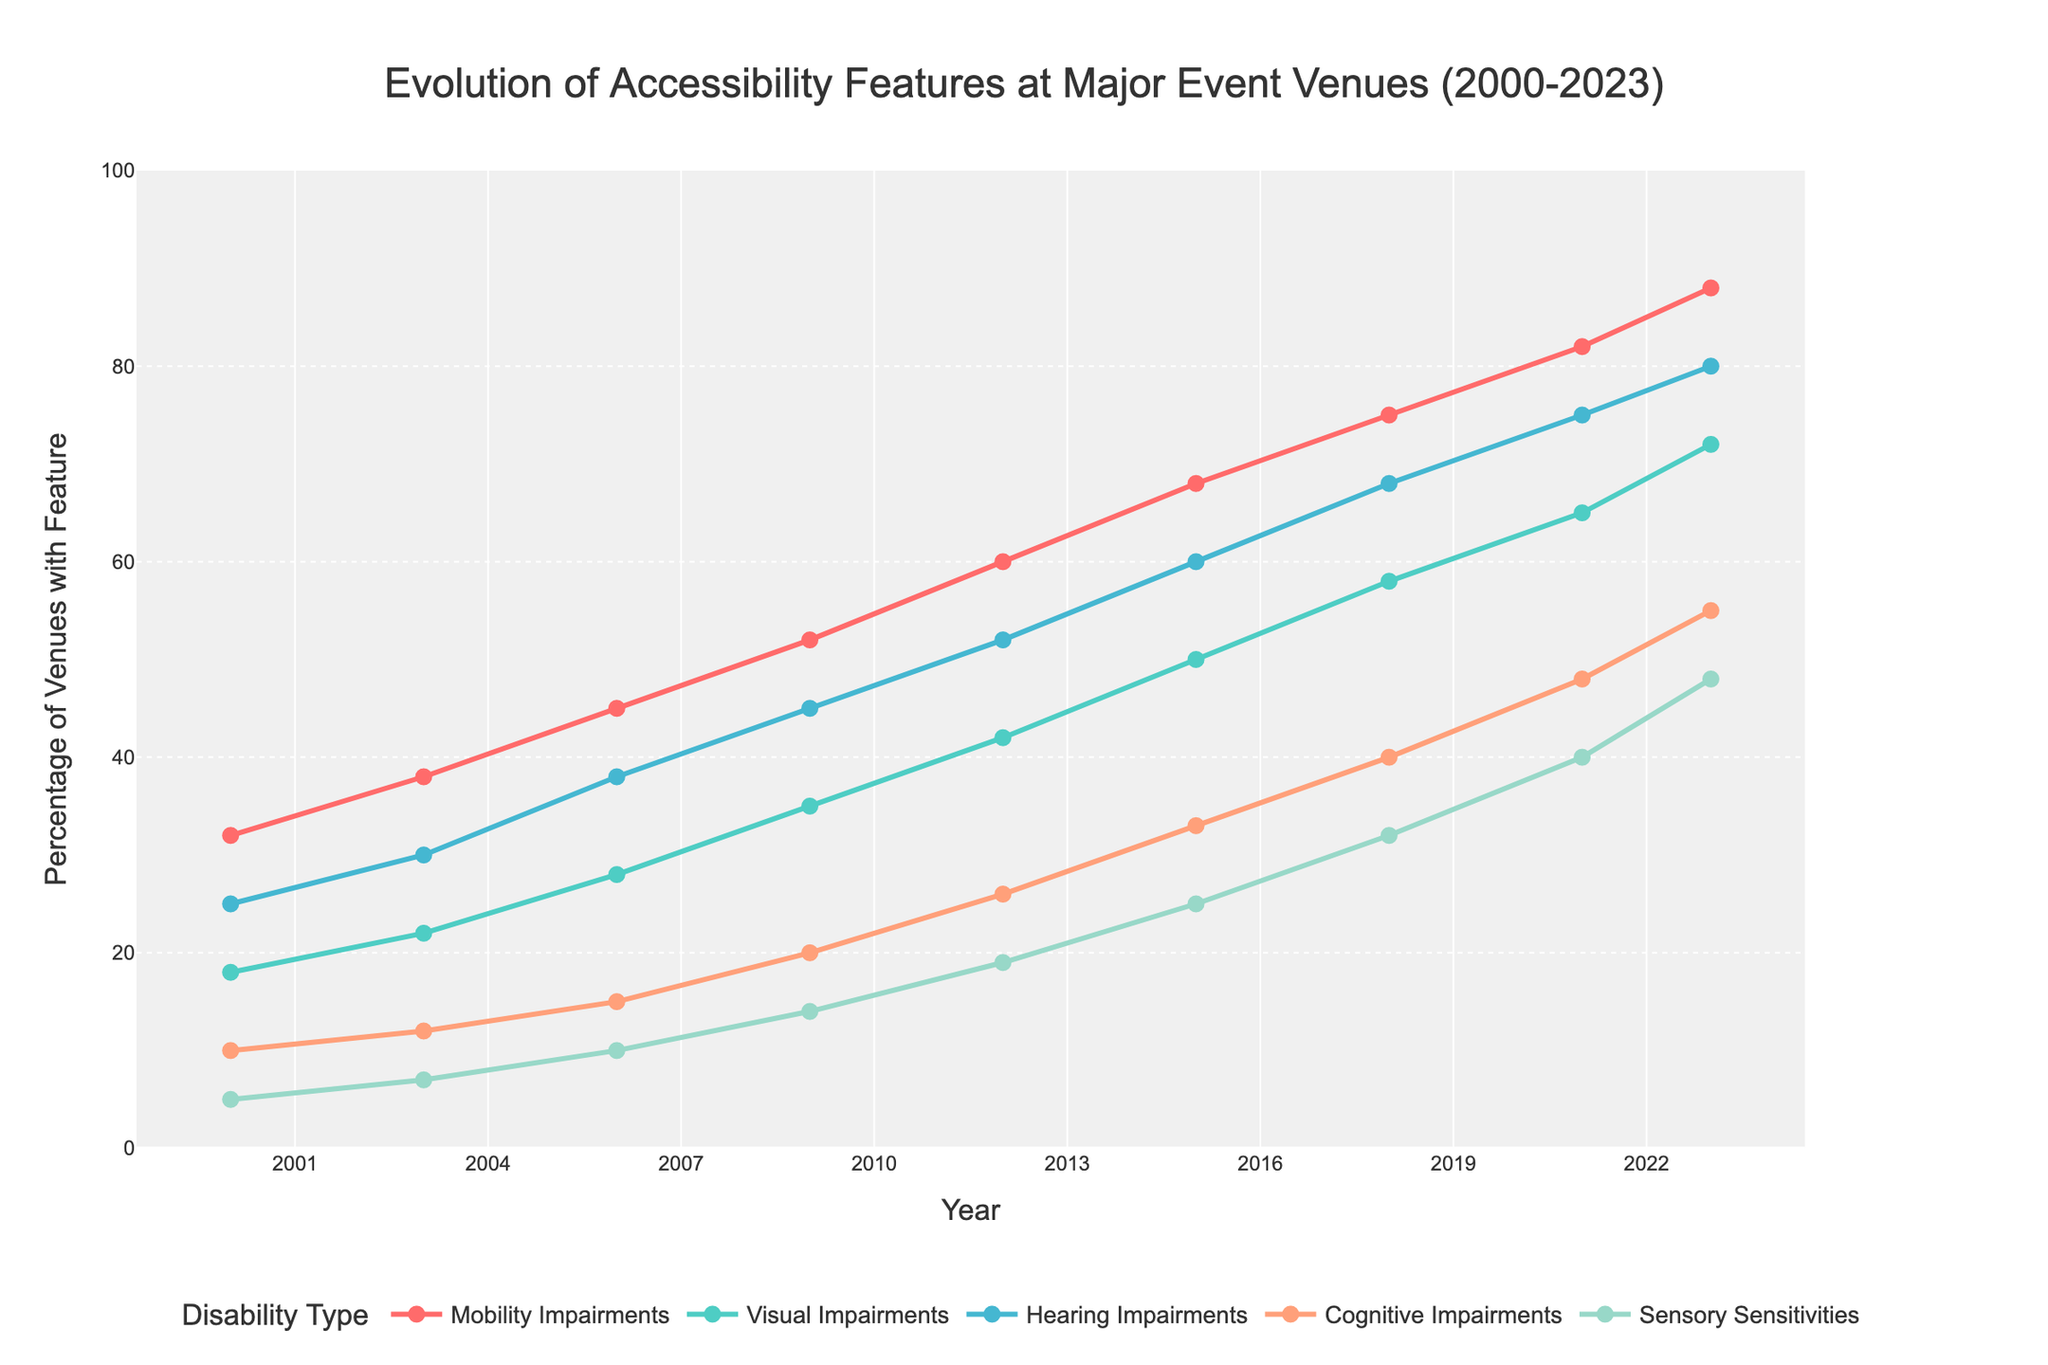What disability type had the greatest increase in the percentage of accessibility features from 2000 to 2023? Find the percentage for each disability type in 2000 and 2023, then calculate the difference. The types and their increases are:
- Mobility Impairments: 88 - 32 = 56
- Visual Impairments: 72 - 18 = 54
- Hearing Impairments: 80 - 25 = 55
- Cognitive Impairments: 55 - 10 = 45
- Sensory Sensitivities: 48 - 5 = 43
Mobility Impairments had the greatest increase of 56.
Answer: Mobility Impairments Between 2015 and 2021, which disability type saw the smallest relative increase in accessibility feature percentage? Calculate the percentage increase for each disability type from 2015 to 2021:
- Mobility Impairments: (82 - 68) / 68 ≈ 0.2059 (20.59%)
- Visual Impairments: (65 - 50) / 50 = 0.30 (30%)
- Hearing Impairments: (75 - 60) / 60 = 0.25 (25%)
- Cognitive Impairments: (48 - 33) / 33 ≈ 0.4545 (45.45%)
- Sensory Sensitivities: (40 - 25) / 25 = 0.60 (60%)
Mobility Impairments saw the smallest relative increase of about 20.59%.
Answer: Mobility Impairments What was the first year in which all disability types had at least 50% accessibility features? Check each year to see when all disability types reached at least 50%:
- 2000: No
- 2003: No
- 2006: No
- 2009: No
- 2012: No
- 2015: No
- 2018: No
- 2021: Yes (all types are 50% or above)
- 2023: Yes
The first year all disability types had at least 50% accessibility features was 2021.
Answer: 2021 What is the difference in the percentage of accessibility features for Visual Impairments between 2003 and 2018? Find the percentages in 2003 and 2018:
- 2003: 22
- 2018: 58
The difference is:
58 - 22 = 36.
Answer: 36 Identify the trend for Cognitive Impairments from 2000 to 2023? List the percentages from 2000 to 2023 for Cognitive Impairments:
- 2000: 10
- 2003: 12
- 2006: 15
- 2009: 20
- 2012: 26
- 2015: 33
- 2018: 40
- 2021: 48
- 2023: 55
The trend shows a steady increase in accessibility features for Cognitive Impairments over time.
Answer: Steady increase 